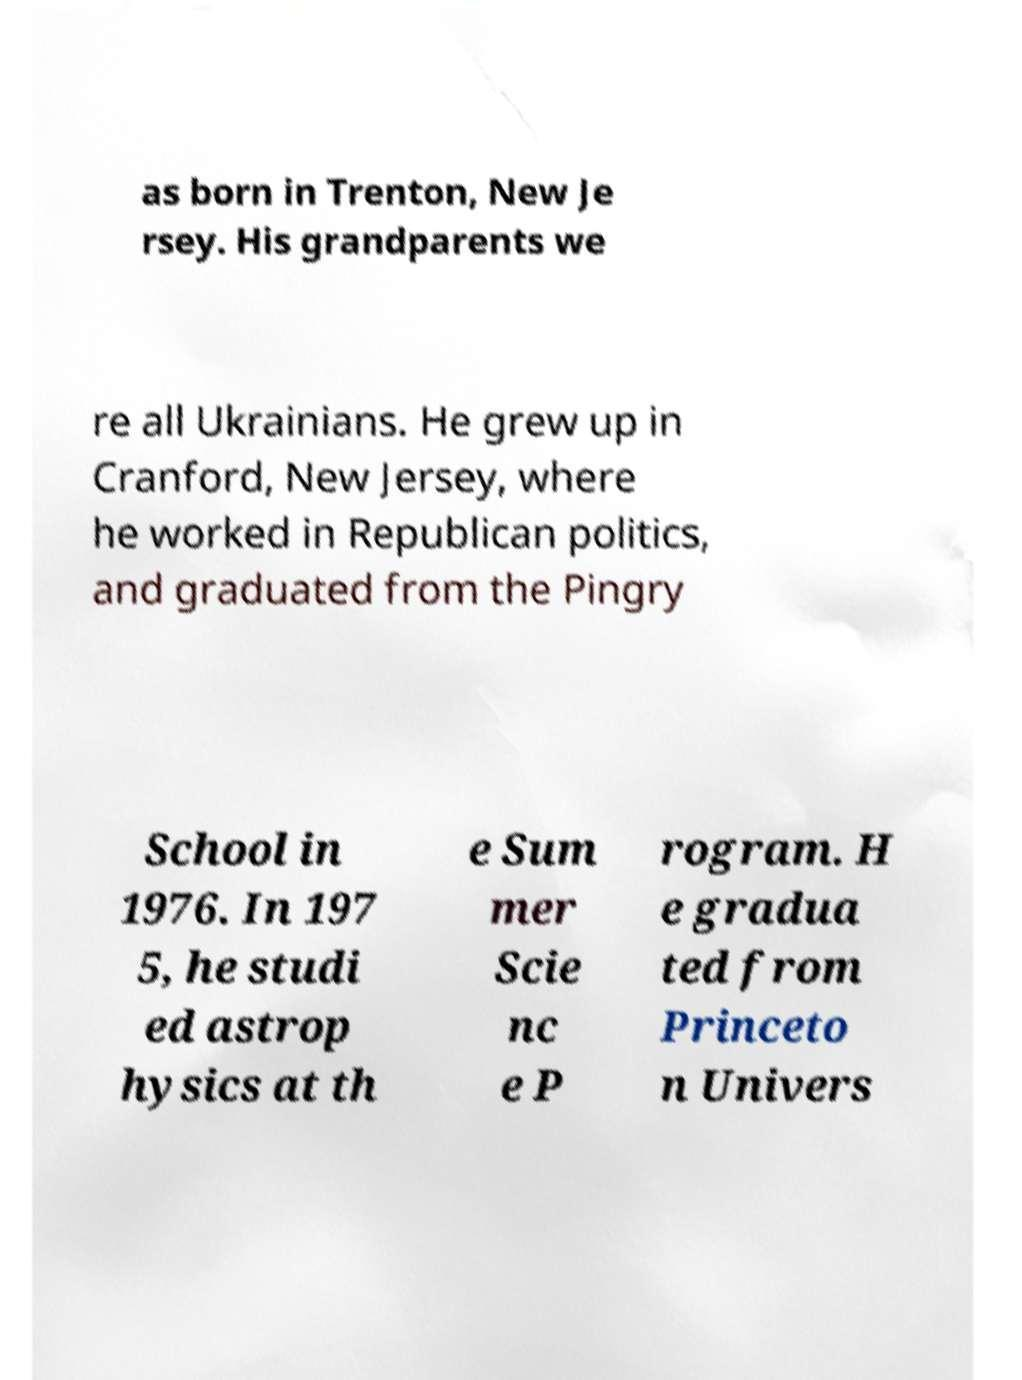Please identify and transcribe the text found in this image. as born in Trenton, New Je rsey. His grandparents we re all Ukrainians. He grew up in Cranford, New Jersey, where he worked in Republican politics, and graduated from the Pingry School in 1976. In 197 5, he studi ed astrop hysics at th e Sum mer Scie nc e P rogram. H e gradua ted from Princeto n Univers 